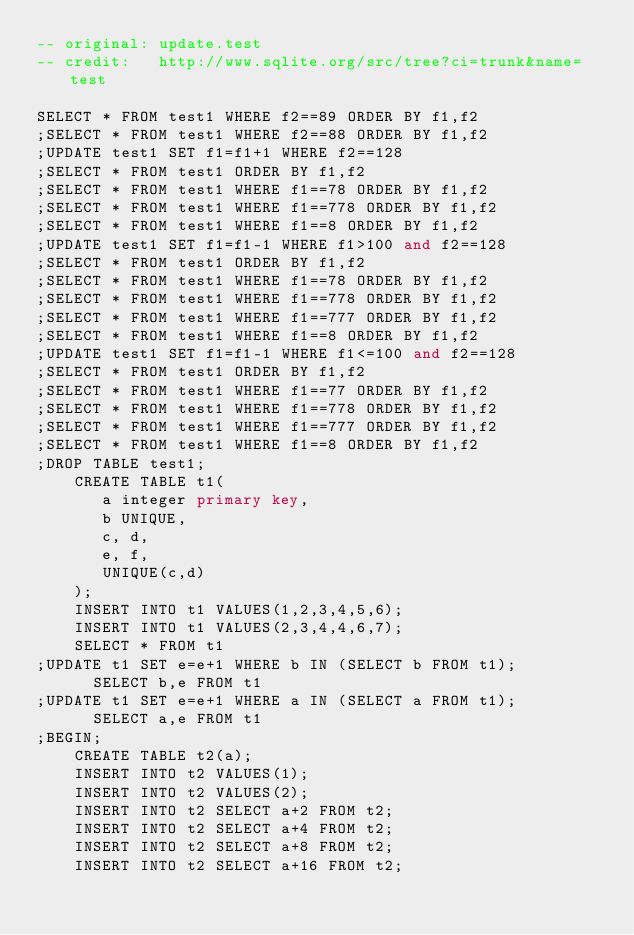Convert code to text. <code><loc_0><loc_0><loc_500><loc_500><_SQL_>-- original: update.test
-- credit:   http://www.sqlite.org/src/tree?ci=trunk&name=test

SELECT * FROM test1 WHERE f2==89 ORDER BY f1,f2
;SELECT * FROM test1 WHERE f2==88 ORDER BY f1,f2
;UPDATE test1 SET f1=f1+1 WHERE f2==128
;SELECT * FROM test1 ORDER BY f1,f2
;SELECT * FROM test1 WHERE f1==78 ORDER BY f1,f2
;SELECT * FROM test1 WHERE f1==778 ORDER BY f1,f2
;SELECT * FROM test1 WHERE f1==8 ORDER BY f1,f2
;UPDATE test1 SET f1=f1-1 WHERE f1>100 and f2==128
;SELECT * FROM test1 ORDER BY f1,f2
;SELECT * FROM test1 WHERE f1==78 ORDER BY f1,f2
;SELECT * FROM test1 WHERE f1==778 ORDER BY f1,f2
;SELECT * FROM test1 WHERE f1==777 ORDER BY f1,f2
;SELECT * FROM test1 WHERE f1==8 ORDER BY f1,f2
;UPDATE test1 SET f1=f1-1 WHERE f1<=100 and f2==128
;SELECT * FROM test1 ORDER BY f1,f2
;SELECT * FROM test1 WHERE f1==77 ORDER BY f1,f2
;SELECT * FROM test1 WHERE f1==778 ORDER BY f1,f2
;SELECT * FROM test1 WHERE f1==777 ORDER BY f1,f2
;SELECT * FROM test1 WHERE f1==8 ORDER BY f1,f2
;DROP TABLE test1;
    CREATE TABLE t1(
       a integer primary key,
       b UNIQUE, 
       c, d,
       e, f,
       UNIQUE(c,d)
    );
    INSERT INTO t1 VALUES(1,2,3,4,5,6);
    INSERT INTO t1 VALUES(2,3,4,4,6,7);
    SELECT * FROM t1
;UPDATE t1 SET e=e+1 WHERE b IN (SELECT b FROM t1);
      SELECT b,e FROM t1
;UPDATE t1 SET e=e+1 WHERE a IN (SELECT a FROM t1);
      SELECT a,e FROM t1
;BEGIN;
    CREATE TABLE t2(a);
    INSERT INTO t2 VALUES(1);
    INSERT INTO t2 VALUES(2);
    INSERT INTO t2 SELECT a+2 FROM t2;
    INSERT INTO t2 SELECT a+4 FROM t2;
    INSERT INTO t2 SELECT a+8 FROM t2;
    INSERT INTO t2 SELECT a+16 FROM t2;</code> 